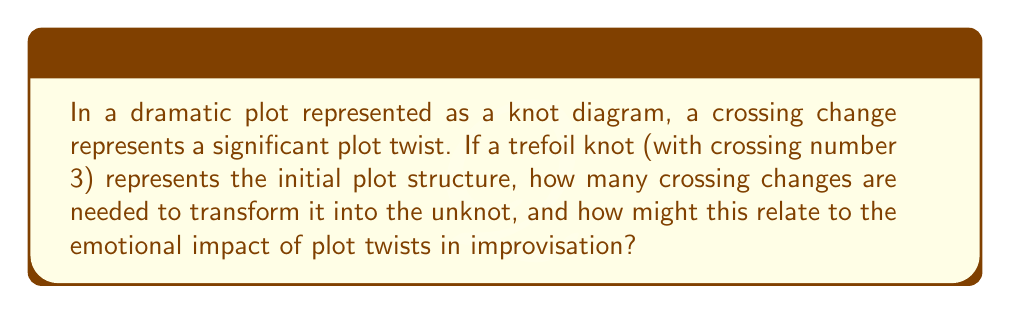Show me your answer to this math problem. To solve this problem, we'll follow these steps:

1. Understand the trefoil knot:
   The trefoil knot is the simplest non-trivial knot, represented by the following diagram:
   [asy]
   import geometry;
   
   path p = (0,0)..(-1,1)..(0,2)..(1,1)..(0,0);
   path q = (0,0)..(1,1)..(0,2)..(-1,1)..(0,0);
   
   draw(p);
   draw(q);
   
   dot((0,0));
   dot((0,2));
   dot((-1,1));
   dot((1,1));
   [/asy]

2. Analyze crossing changes:
   Each crossing in the trefoil knot can be changed from an overcrossing to an undercrossing or vice versa. The trefoil knot has 3 crossings.

3. Determine the minimum number of crossing changes:
   To transform the trefoil knot into the unknot, we need to change at least one crossing. In fact, changing any one of the three crossings is sufficient to unknot the trefoil.

4. Relate to emotional impact in improvisation:
   In terms of plot structure and improvisation, each crossing change represents a significant plot twist. The fact that only one change is needed to completely alter the structure (from a non-trivial knot to the unknot) suggests that a single, well-placed plot twist can dramatically change the entire emotional trajectory of a story.

5. Mathematical representation:
   Let $K$ be the trefoil knot and $U$ be the unknot. The minimum number of crossing changes $c(K,U)$ to transform $K$ into $U$ is given by:

   $$c(K,U) = 1$$

   This is known as the "unknotting number" of the trefoil knot.

6. Improvisation insight:
   The unknotting number being 1 implies that an improviser can create a profound emotional shift with a single, strategically placed plot twist, much like how a single crossing change can fundamentally alter the knot's structure.
Answer: 1 crossing change; represents a single, impactful plot twist 